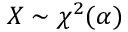<formula> <loc_0><loc_0><loc_500><loc_500>X \sim \chi ^ { 2 } ( \alpha )</formula> 